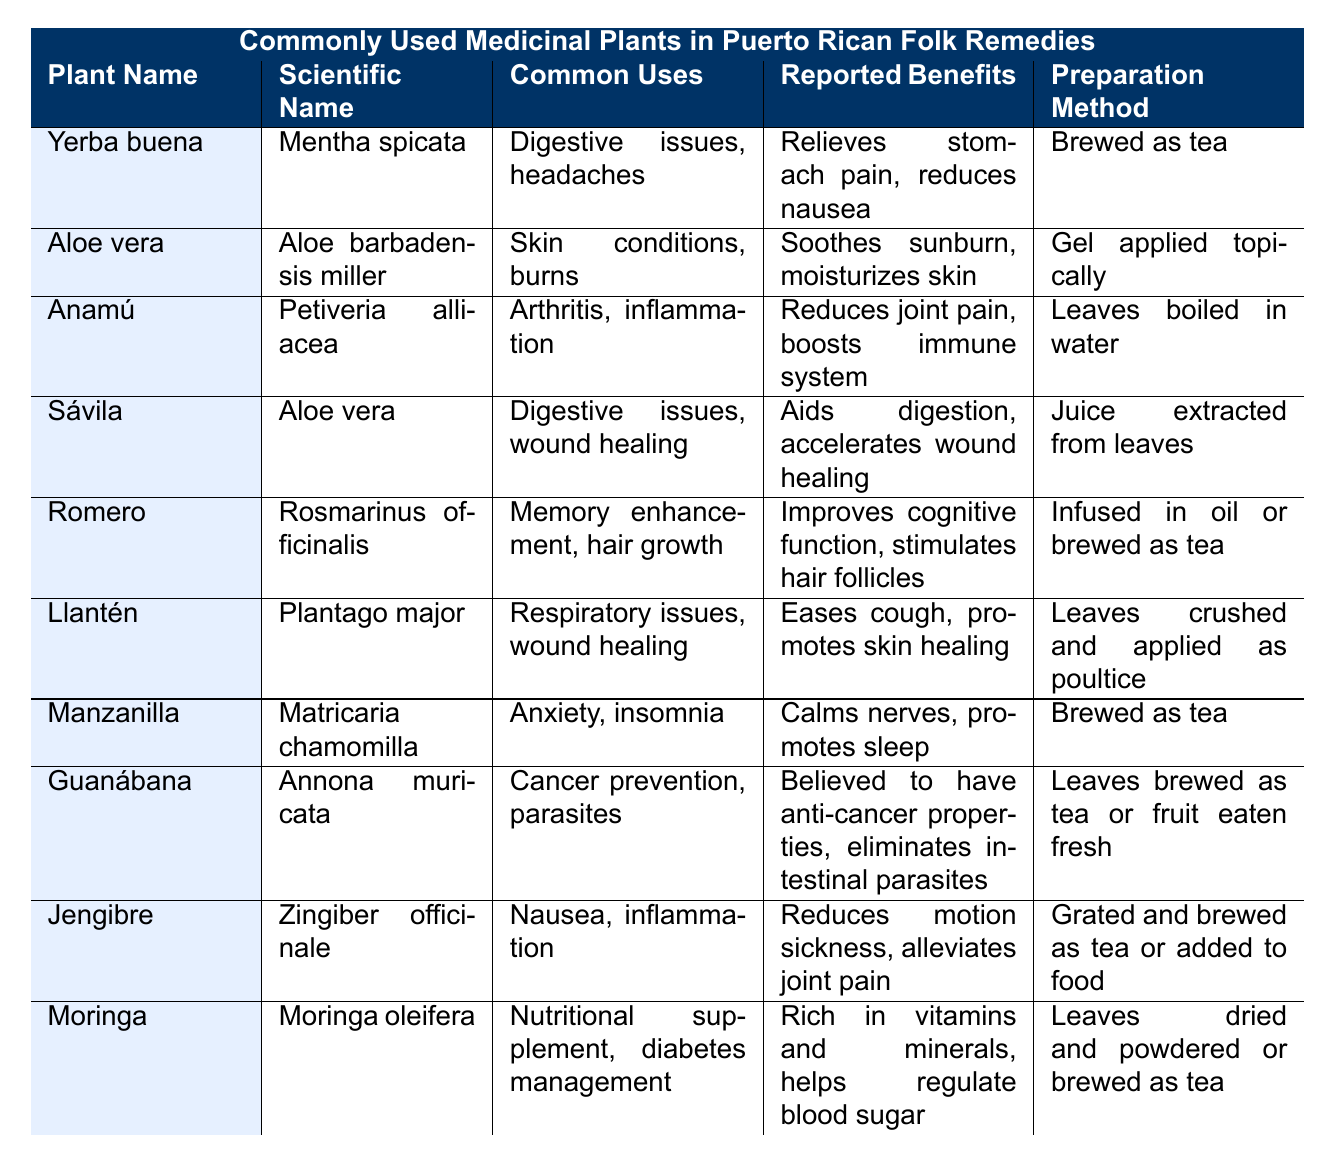What is the scientific name of Yerba buena? The table lists "Yerba buena" and its corresponding scientific name is "Mentha spicata".
Answer: Mentha spicata Which plant is reported to help with anxiety and insomnia? By looking at the "Common Uses" column in the table, "Manzanilla" is the plant listed for anxiety and insomnia.
Answer: Manzanilla How does Aloe vera benefit the skin? The table states that Aloe vera is reported to "soothe sunburn" and "moisturize skin".
Answer: Soothes sunburn, moisturizes skin What preparation method is used for Anamú? The table indicates that Anamú's leaves are "boiled in water" for preparation.
Answer: Leaves boiled in water Is it true that Llantén eases cough? The table shows that one of the reported benefits of Llantén is to "ease cough". Thus, it is true.
Answer: Yes Which plant has multiple preparation methods for its uses? The table lists Aloe vera with different preparation methods; both as gel applied topically and juice extracted from leaves.
Answer: Aloe vera What are the common uses of Moringa? Moringa is noted for being used as a "nutritional supplement" and for "diabetes management".
Answer: Nutritional supplement, diabetes management Which plant is associated with improving cognitive function? The table states that "Romero" is linked to improving cognitive function under the reported benefits section.
Answer: Romero How many plants listed report benefits related to digestive issues? The table lists four plants with digestive benefits: Yerba buena, Sávila, and Moringa.
Answer: Three plants What benefits does Guanábana claim regarding cancer? The table indicates that Guanábana is "believed to have anti-cancer properties" in the reported benefits.
Answer: Believed to have anti-cancer properties 